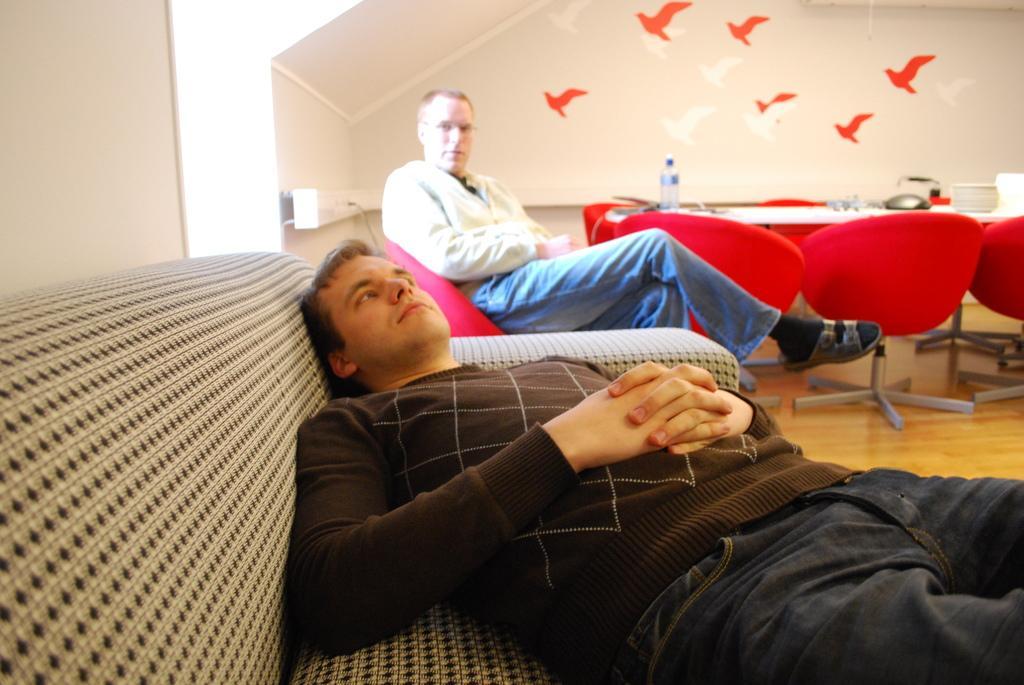Please provide a concise description of this image. In this picture we can see two man one is sitting on chair and other is sleeping on sofa and in the background we can see wall with birds, chairs and on table we can see bottle. 